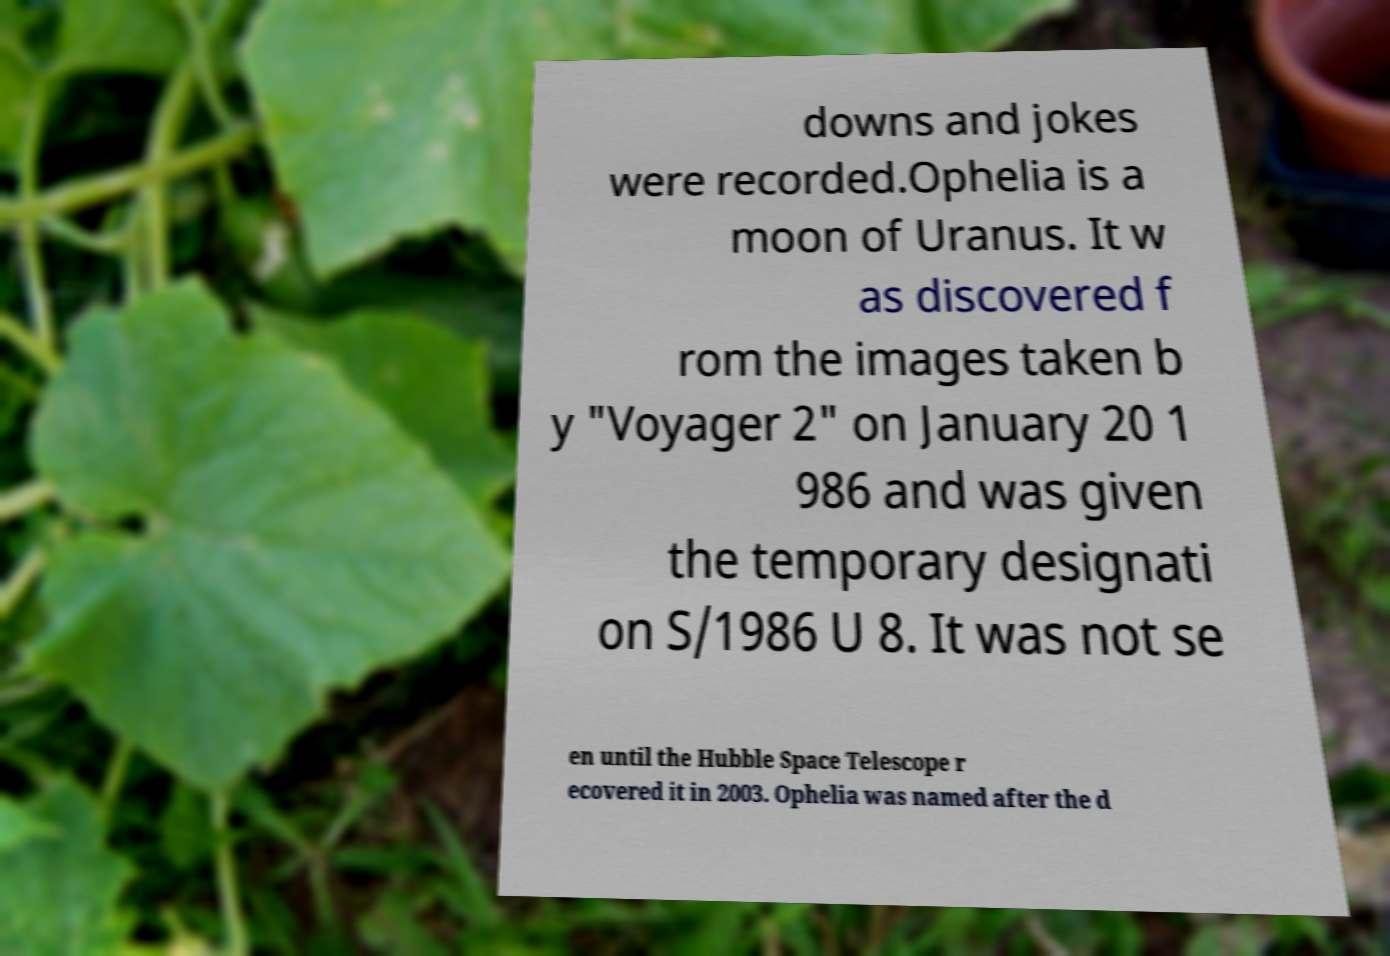Could you assist in decoding the text presented in this image and type it out clearly? downs and jokes were recorded.Ophelia is a moon of Uranus. It w as discovered f rom the images taken b y "Voyager 2" on January 20 1 986 and was given the temporary designati on S/1986 U 8. It was not se en until the Hubble Space Telescope r ecovered it in 2003. Ophelia was named after the d 